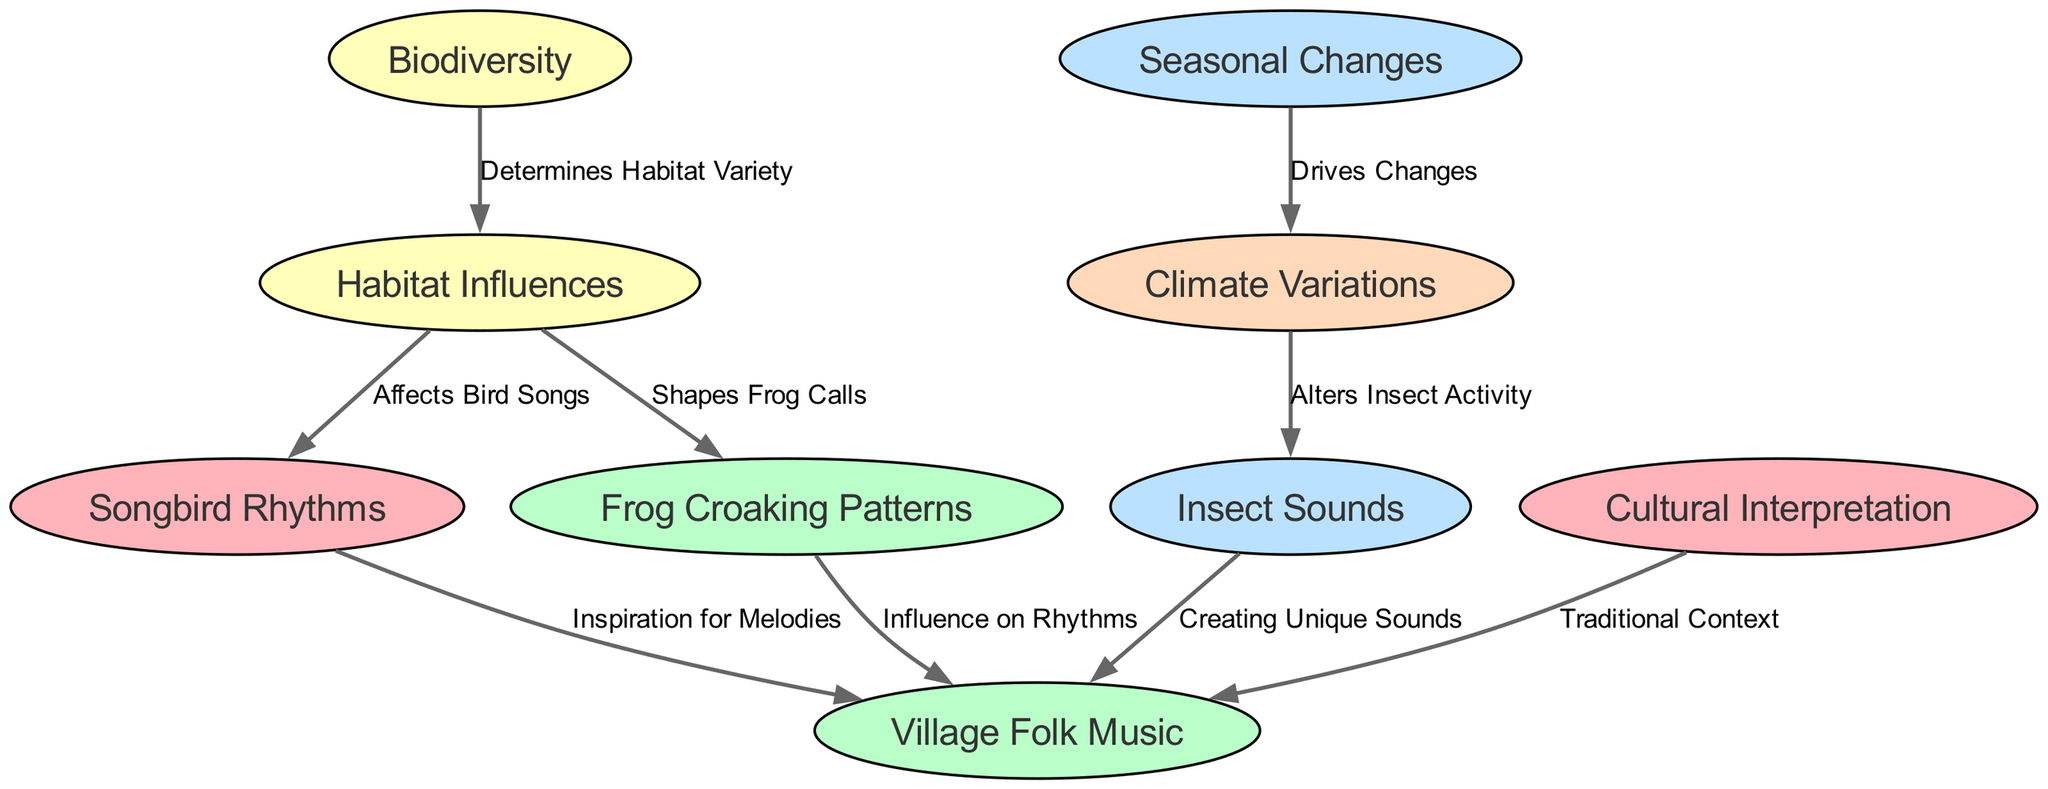What is the number of nodes in the diagram? The diagram features a total of 9 nodes representing various musical and ecological concepts.
Answer: 9 Who influences the rhythms in village folk music? Frog croaking patterns influence the rhythms in village folk music directly as indicated by the edge connecting them.
Answer: Frog Croaking Patterns How does habitat influence songbird rhythms? The edge indicates that habitat influences songbird rhythms by affecting bird songs, which ties both nodes together.
Answer: Affects Bird Songs What drives changes in climate variations? Seasonal changes drive climate variations, as shown by the edge that directly connects these two nodes in the diagram.
Answer: Drives Changes Which node is related to cultural interpretation? The cultural interpretation node is connected to the village folk music node, indicating a direct relationship.
Answer: Traditional Context What nodes are directly linked to the village folk music? Songbird rhythms, frog croaking patterns, insect sounds, and cultural interpretation nodes are all directly linked to village folk music.
Answer: Songbird Rhythms, Frog Croaking Patterns, Insect Sounds, and Cultural Interpretation How does biodiversity influence habitat variety? Biodiversity determines habitat variety, which is shown by the edge connecting these two nodes, highlighting their relationship.
Answer: Determines Habitat Variety Which factor alters insect activity? Climate variations alter insect activity, as specifically indicated by the edge that connects these two nodes in the diagram.
Answer: Alters Insect Activity What relationships are illustrated by the edges in the diagram? The relationships illustrated in the diagram show how various ecological factors and animal sounds inspire and influence traditional rhythms and sounds in village music.
Answer: Ecological factors and animal sounds influence traditional rhythms 